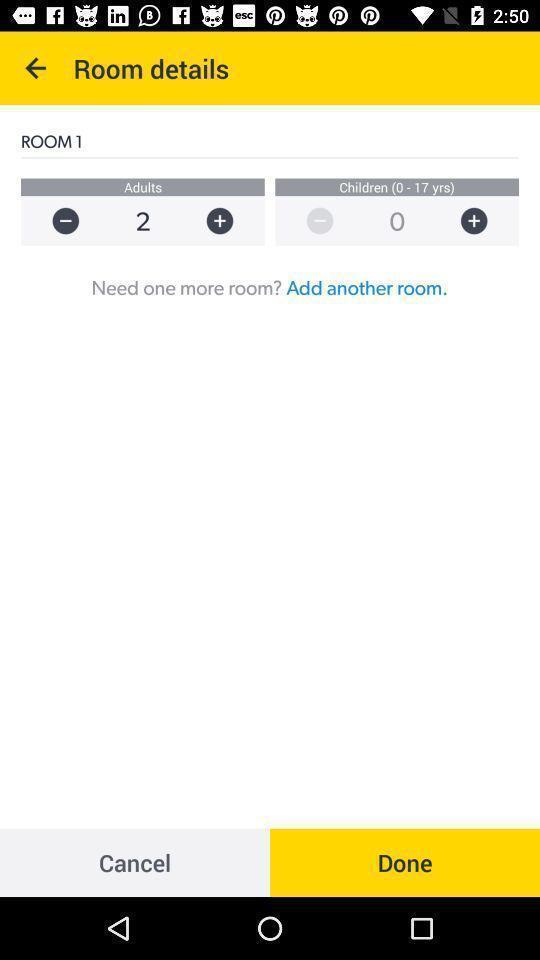Please provide a description for this image. Page displaying room details in app. 